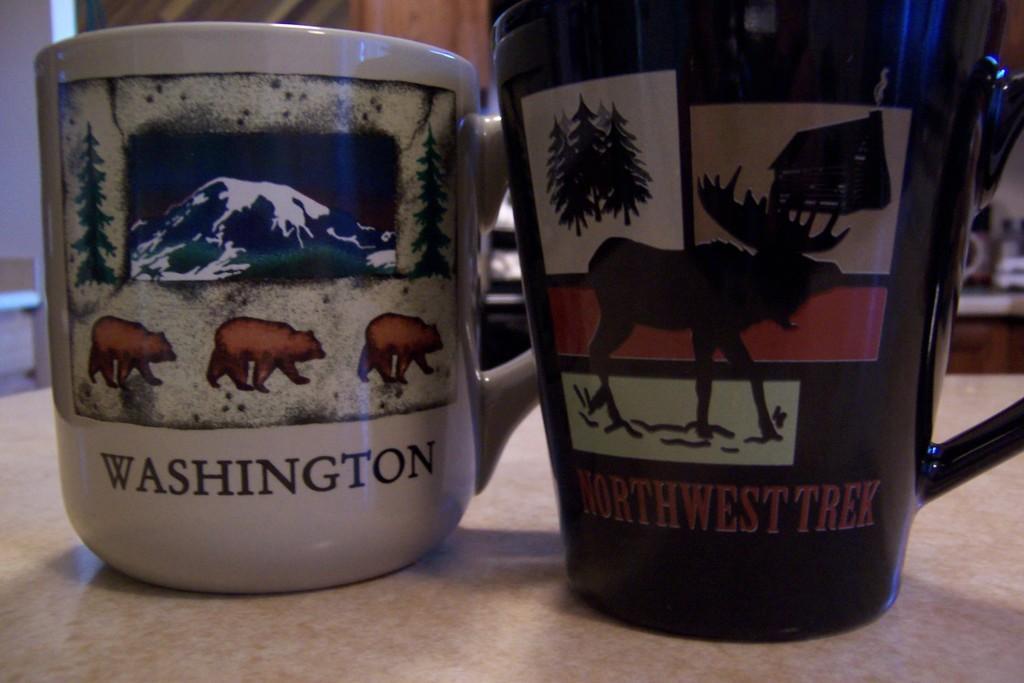In one or two sentences, can you explain what this image depicts? In this image there are two mugs on a table. 